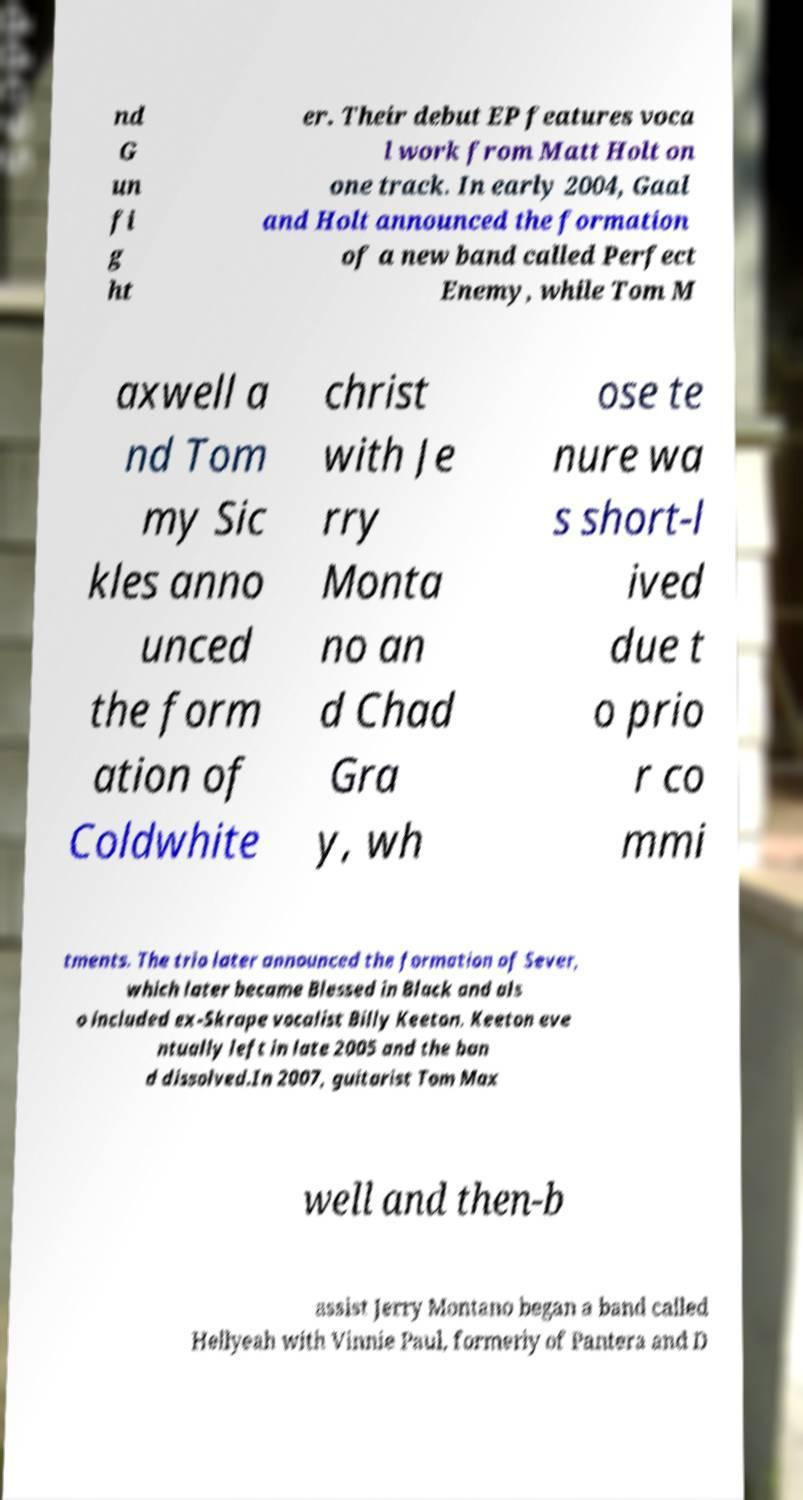Can you accurately transcribe the text from the provided image for me? nd G un fi g ht er. Their debut EP features voca l work from Matt Holt on one track. In early 2004, Gaal and Holt announced the formation of a new band called Perfect Enemy, while Tom M axwell a nd Tom my Sic kles anno unced the form ation of Coldwhite christ with Je rry Monta no an d Chad Gra y, wh ose te nure wa s short-l ived due t o prio r co mmi tments. The trio later announced the formation of Sever, which later became Blessed in Black and als o included ex-Skrape vocalist Billy Keeton. Keeton eve ntually left in late 2005 and the ban d dissolved.In 2007, guitarist Tom Max well and then-b assist Jerry Montano began a band called Hellyeah with Vinnie Paul, formerly of Pantera and D 